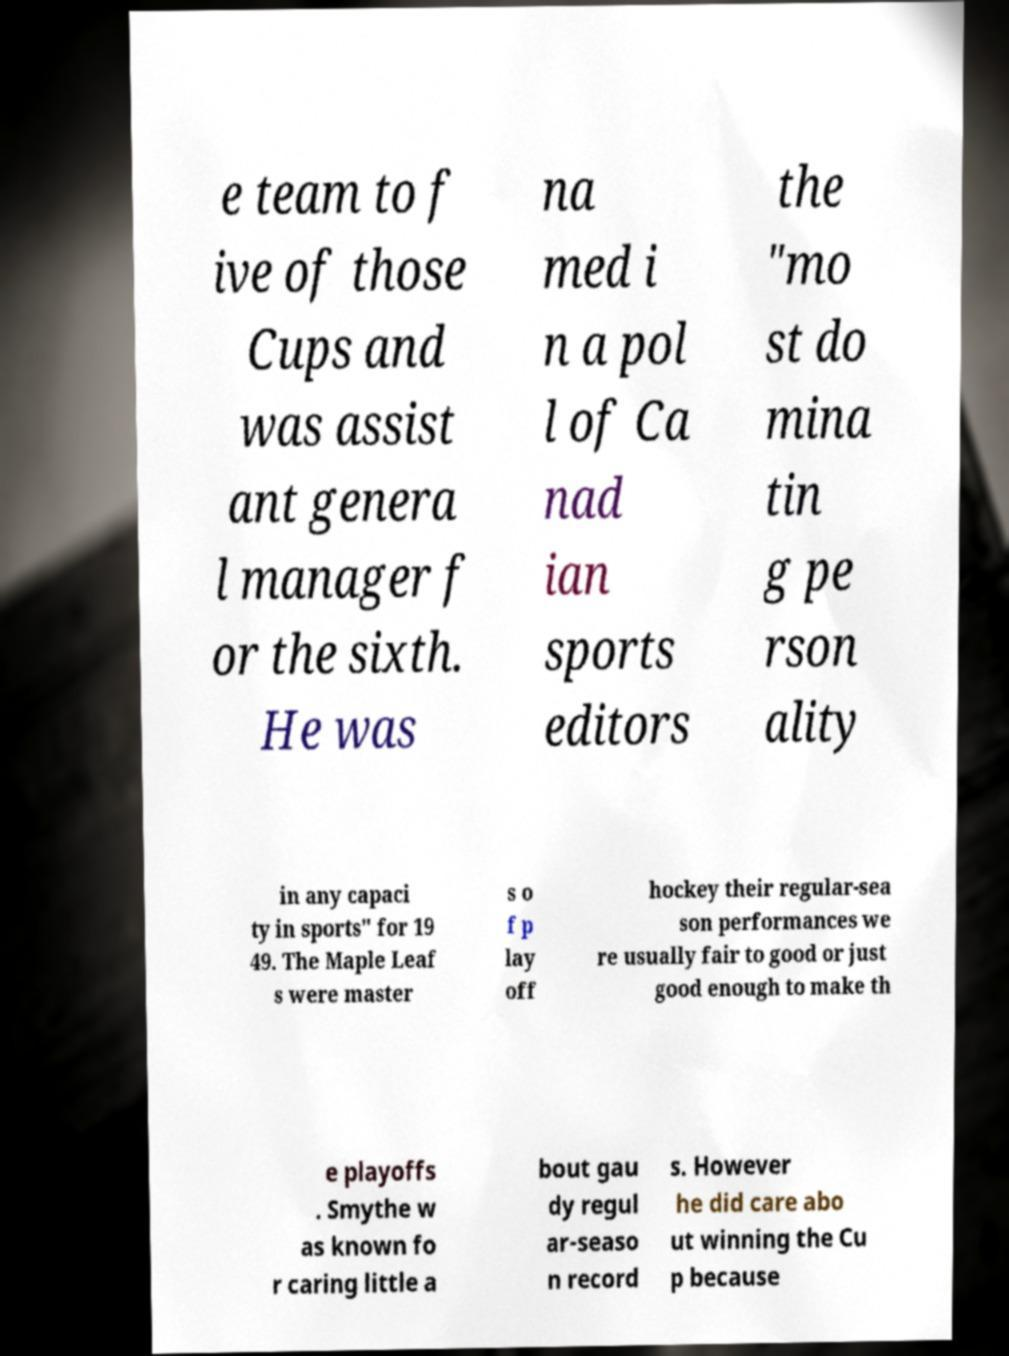Please identify and transcribe the text found in this image. e team to f ive of those Cups and was assist ant genera l manager f or the sixth. He was na med i n a pol l of Ca nad ian sports editors the "mo st do mina tin g pe rson ality in any capaci ty in sports" for 19 49. The Maple Leaf s were master s o f p lay off hockey their regular-sea son performances we re usually fair to good or just good enough to make th e playoffs . Smythe w as known fo r caring little a bout gau dy regul ar-seaso n record s. However he did care abo ut winning the Cu p because 